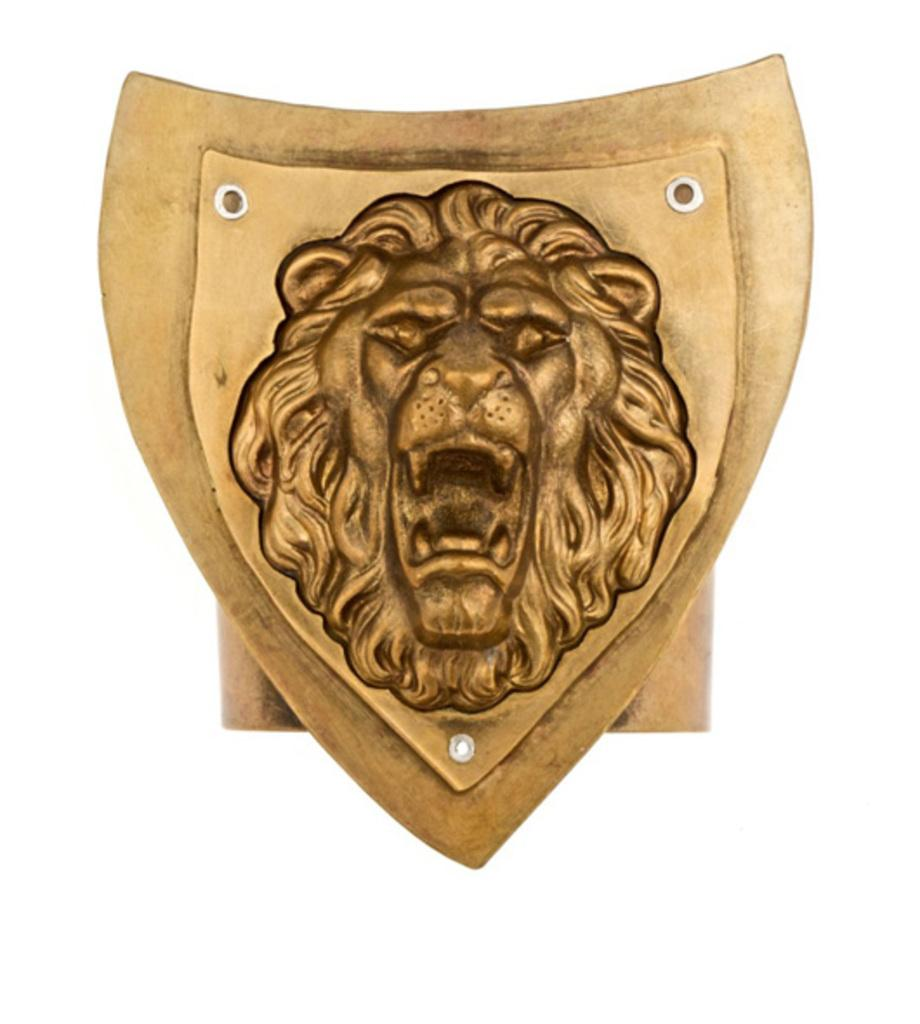What is the shape of the shield in the image? The shield in the image is lion shaped. What color is the lion shaped shield? The shield is brown in color. Are there any cobwebs visible on the lion shaped shield in the image? There is no mention of cobwebs in the image, and the image does not show any cobwebs on the shield. 